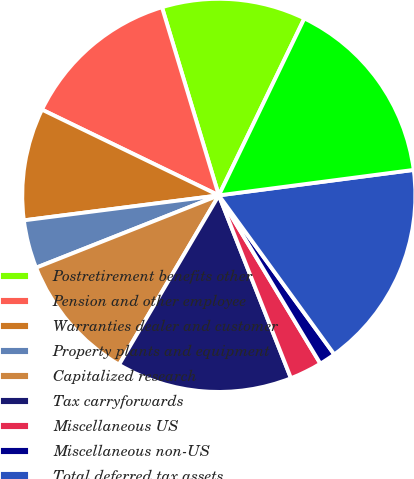<chart> <loc_0><loc_0><loc_500><loc_500><pie_chart><fcel>Postretirement benefits other<fcel>Pension and other employee<fcel>Warranties dealer and customer<fcel>Property plants and equipment<fcel>Capitalized research<fcel>Tax carryforwards<fcel>Miscellaneous US<fcel>Miscellaneous non-US<fcel>Total deferred tax assets<fcel>Less Valuation allowances<nl><fcel>11.83%<fcel>13.14%<fcel>9.21%<fcel>3.97%<fcel>10.52%<fcel>14.45%<fcel>2.66%<fcel>1.35%<fcel>17.07%<fcel>15.76%<nl></chart> 